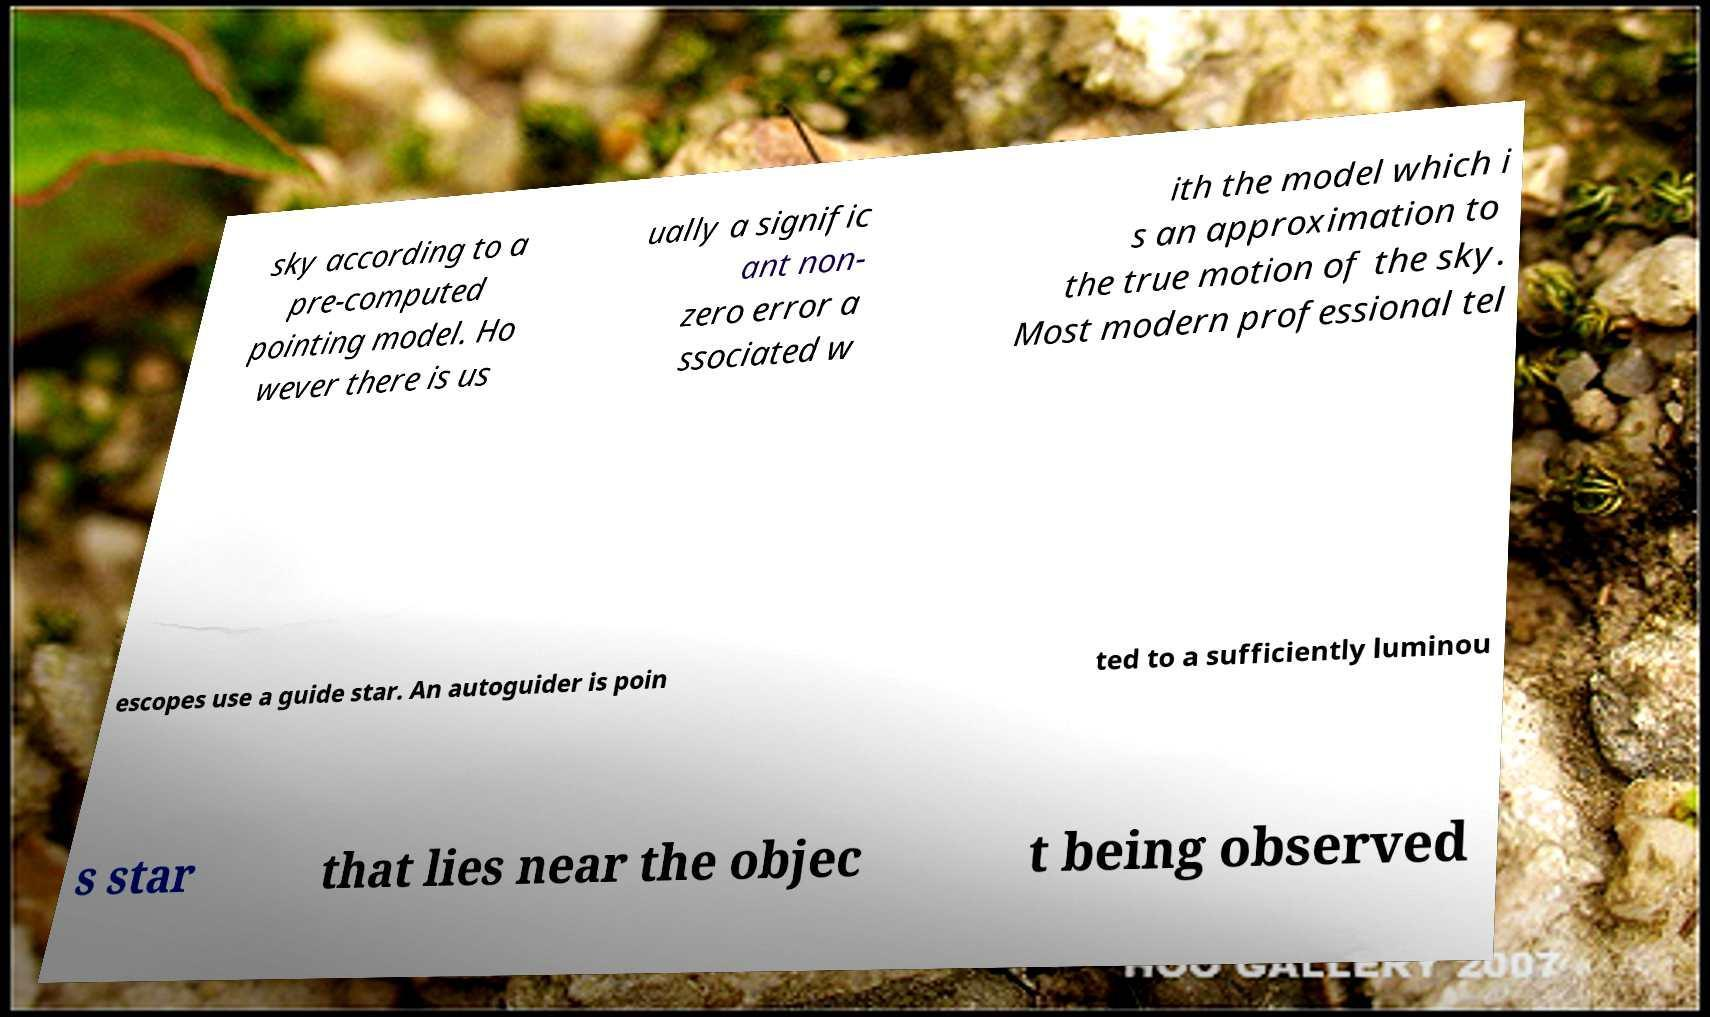Can you read and provide the text displayed in the image?This photo seems to have some interesting text. Can you extract and type it out for me? sky according to a pre-computed pointing model. Ho wever there is us ually a signific ant non- zero error a ssociated w ith the model which i s an approximation to the true motion of the sky. Most modern professional tel escopes use a guide star. An autoguider is poin ted to a sufficiently luminou s star that lies near the objec t being observed 